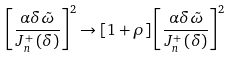Convert formula to latex. <formula><loc_0><loc_0><loc_500><loc_500>\left [ \frac { \alpha \delta \tilde { \omega } } { J _ { n } ^ { + } \left ( \delta \right ) } \right ] ^ { 2 } \rightarrow \left [ 1 + \rho \right ] \left [ \frac { \alpha \delta \tilde { \omega } } { J _ { n } ^ { + } \left ( \delta \right ) } \right ] ^ { 2 }</formula> 